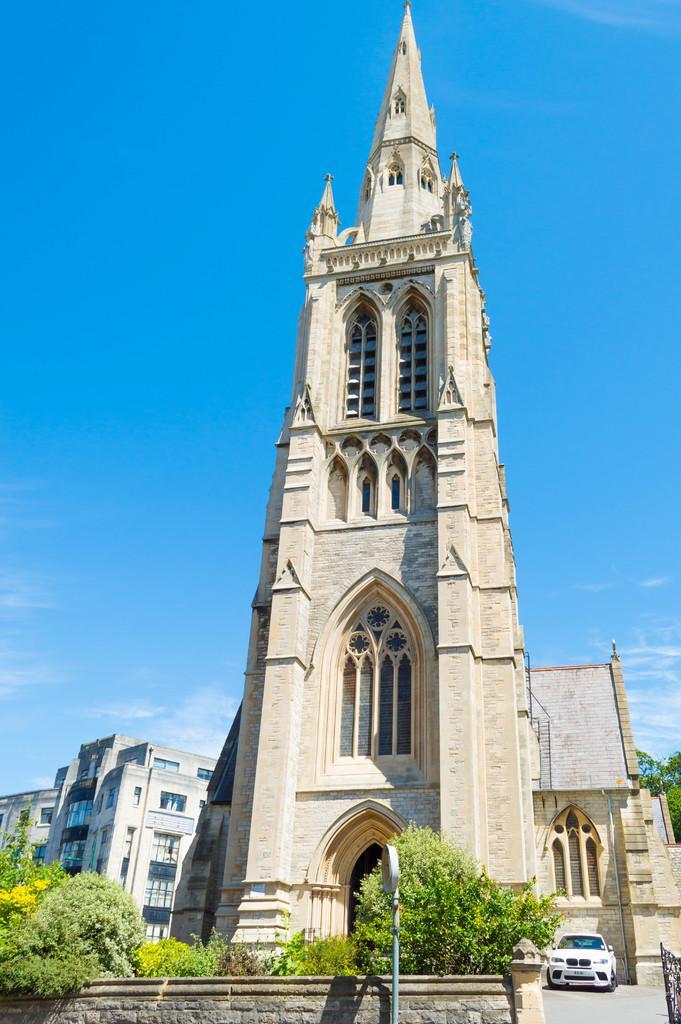Can you describe this image briefly? In this picture I can see there is a building here and there is a car parked here and there are plants, trees and in the backdrop there are some other buildings and trees. 